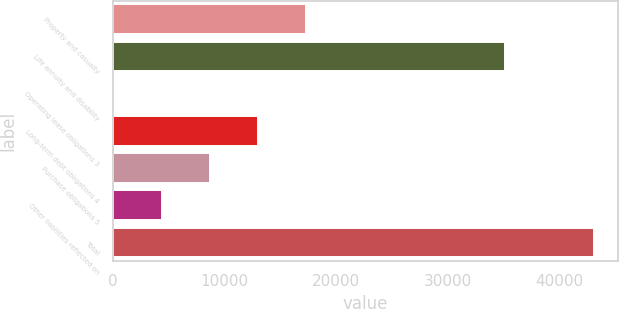Convert chart to OTSL. <chart><loc_0><loc_0><loc_500><loc_500><bar_chart><fcel>Property and casualty<fcel>Life annuity and disability<fcel>Operating lease obligations 3<fcel>Long-term debt obligations 4<fcel>Purchase obligations 5<fcel>Other liabilities reflected on<fcel>Total<nl><fcel>17256.4<fcel>35122<fcel>64<fcel>12958.3<fcel>8660.2<fcel>4362.1<fcel>43045<nl></chart> 